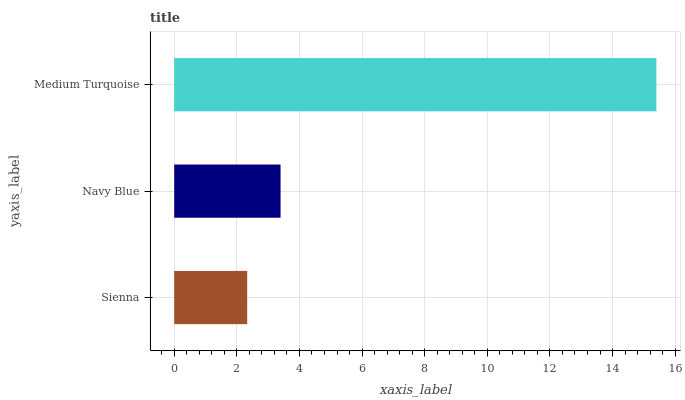Is Sienna the minimum?
Answer yes or no. Yes. Is Medium Turquoise the maximum?
Answer yes or no. Yes. Is Navy Blue the minimum?
Answer yes or no. No. Is Navy Blue the maximum?
Answer yes or no. No. Is Navy Blue greater than Sienna?
Answer yes or no. Yes. Is Sienna less than Navy Blue?
Answer yes or no. Yes. Is Sienna greater than Navy Blue?
Answer yes or no. No. Is Navy Blue less than Sienna?
Answer yes or no. No. Is Navy Blue the high median?
Answer yes or no. Yes. Is Navy Blue the low median?
Answer yes or no. Yes. Is Medium Turquoise the high median?
Answer yes or no. No. Is Sienna the low median?
Answer yes or no. No. 